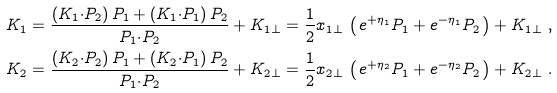<formula> <loc_0><loc_0><loc_500><loc_500>K _ { 1 } & = \frac { ( K _ { 1 } { \cdot } P _ { 2 } ) \, P _ { 1 } + ( K _ { 1 } { \cdot } P _ { 1 } ) \, P _ { 2 } } { P _ { 1 } { \cdot } P _ { 2 } } + K _ { 1 \perp } = \frac { 1 } { 2 } x _ { 1 \perp } \, \left ( \, e ^ { + \eta _ { 1 } } P _ { 1 } + e ^ { - \eta _ { 1 } } P _ { 2 } \, \right ) + K _ { 1 \perp } \ , \\ K _ { 2 } & = \frac { ( K _ { 2 } { \cdot } P _ { 2 } ) \, P _ { 1 } + ( K _ { 2 } { \cdot } P _ { 1 } ) \, P _ { 2 } } { P _ { 1 } { \cdot } P _ { 2 } } + K _ { 2 \perp } = \frac { 1 } { 2 } x _ { 2 \perp } \, \left ( \, e ^ { + \eta _ { 2 } } P _ { 1 } + e ^ { - \eta _ { 2 } } P _ { 2 } \, \right ) + K _ { 2 \perp } \ .</formula> 